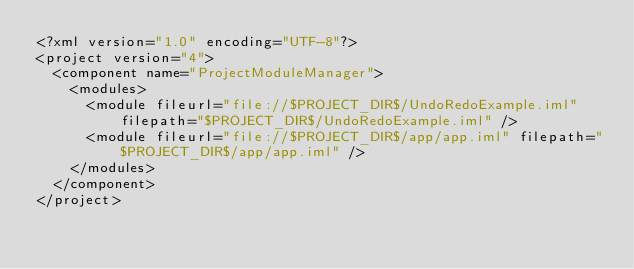Convert code to text. <code><loc_0><loc_0><loc_500><loc_500><_XML_><?xml version="1.0" encoding="UTF-8"?>
<project version="4">
  <component name="ProjectModuleManager">
    <modules>
      <module fileurl="file://$PROJECT_DIR$/UndoRedoExample.iml" filepath="$PROJECT_DIR$/UndoRedoExample.iml" />
      <module fileurl="file://$PROJECT_DIR$/app/app.iml" filepath="$PROJECT_DIR$/app/app.iml" />
    </modules>
  </component>
</project></code> 